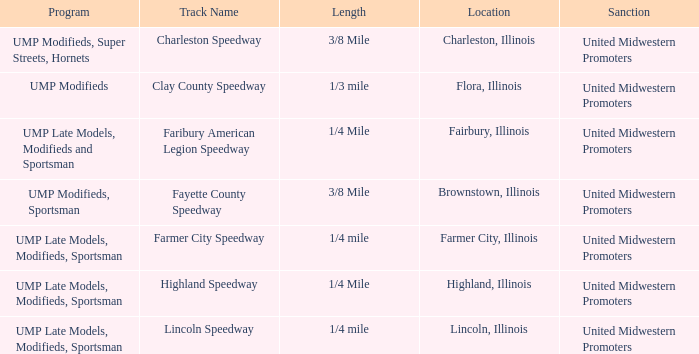What programs were held in charleston, illinois? UMP Modifieds, Super Streets, Hornets. 